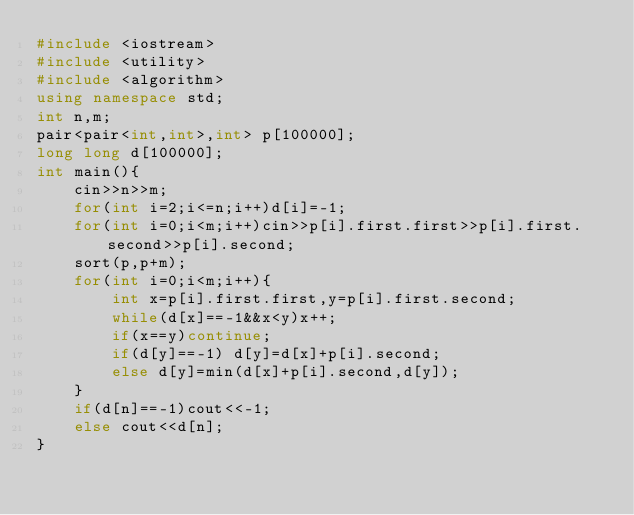<code> <loc_0><loc_0><loc_500><loc_500><_C++_>#include <iostream>
#include <utility>
#include <algorithm>
using namespace std;
int n,m;
pair<pair<int,int>,int> p[100000];
long long d[100000];
int main(){
    cin>>n>>m;
    for(int i=2;i<=n;i++)d[i]=-1;
    for(int i=0;i<m;i++)cin>>p[i].first.first>>p[i].first.second>>p[i].second;
    sort(p,p+m);
    for(int i=0;i<m;i++){
        int x=p[i].first.first,y=p[i].first.second;
        while(d[x]==-1&&x<y)x++;
        if(x==y)continue;
        if(d[y]==-1) d[y]=d[x]+p[i].second;
        else d[y]=min(d[x]+p[i].second,d[y]);
    }
    if(d[n]==-1)cout<<-1;
    else cout<<d[n];
}</code> 